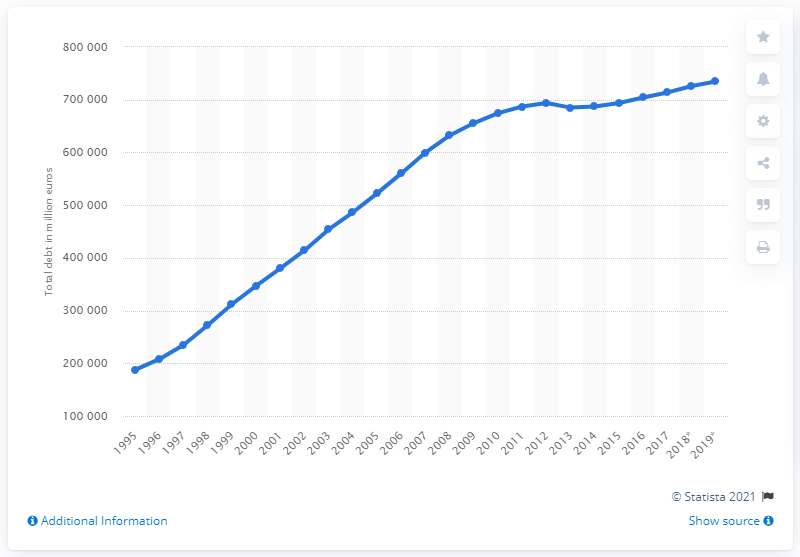List a handful of essential elements in this visual. At the end of 2019, the outstanding mortgage loans in the Netherlands totaled 734,556. 